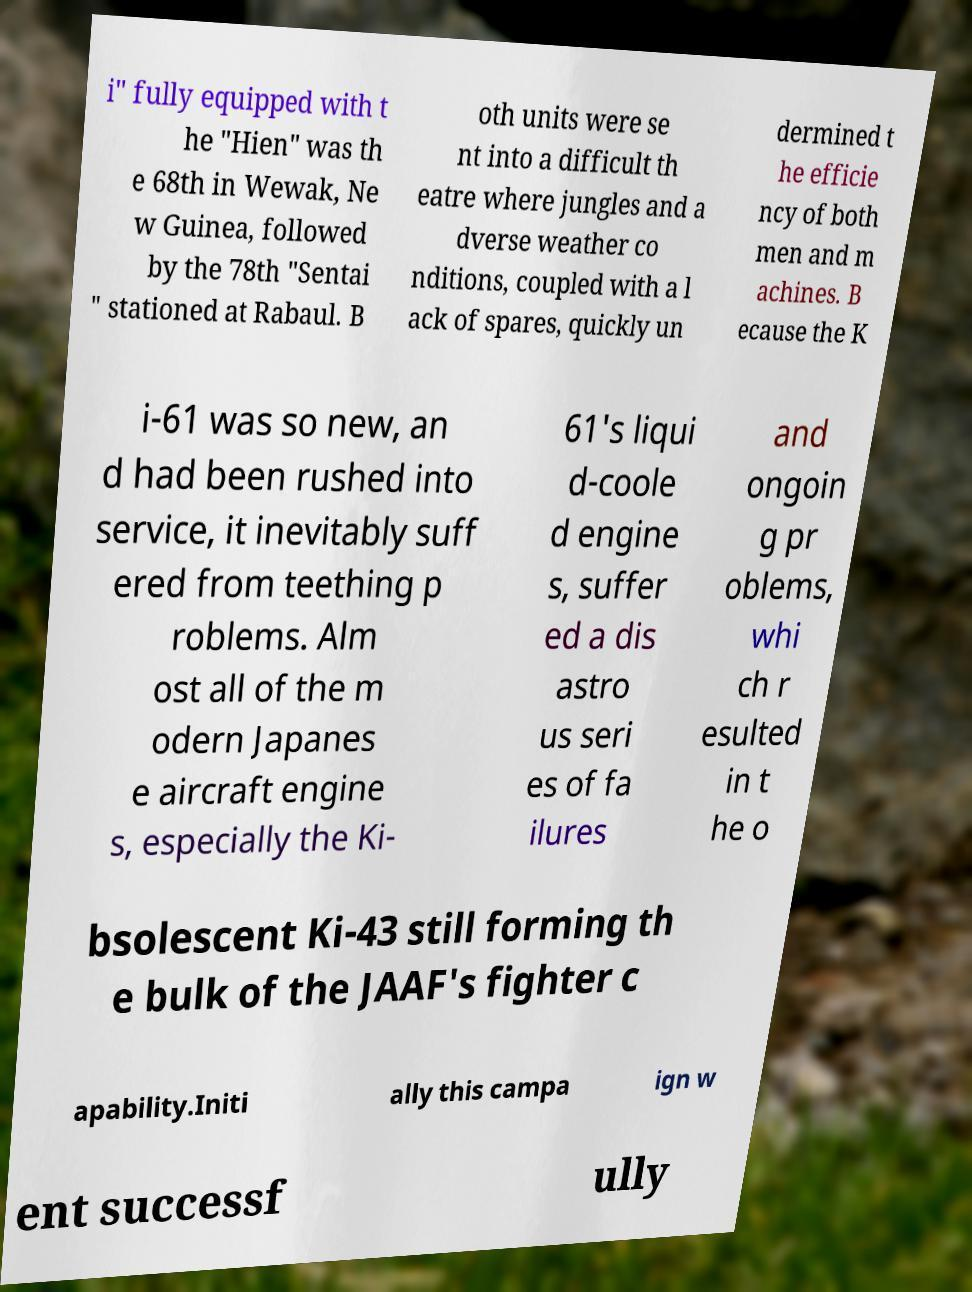What messages or text are displayed in this image? I need them in a readable, typed format. i" fully equipped with t he "Hien" was th e 68th in Wewak, Ne w Guinea, followed by the 78th "Sentai " stationed at Rabaul. B oth units were se nt into a difficult th eatre where jungles and a dverse weather co nditions, coupled with a l ack of spares, quickly un dermined t he efficie ncy of both men and m achines. B ecause the K i-61 was so new, an d had been rushed into service, it inevitably suff ered from teething p roblems. Alm ost all of the m odern Japanes e aircraft engine s, especially the Ki- 61's liqui d-coole d engine s, suffer ed a dis astro us seri es of fa ilures and ongoin g pr oblems, whi ch r esulted in t he o bsolescent Ki-43 still forming th e bulk of the JAAF's fighter c apability.Initi ally this campa ign w ent successf ully 